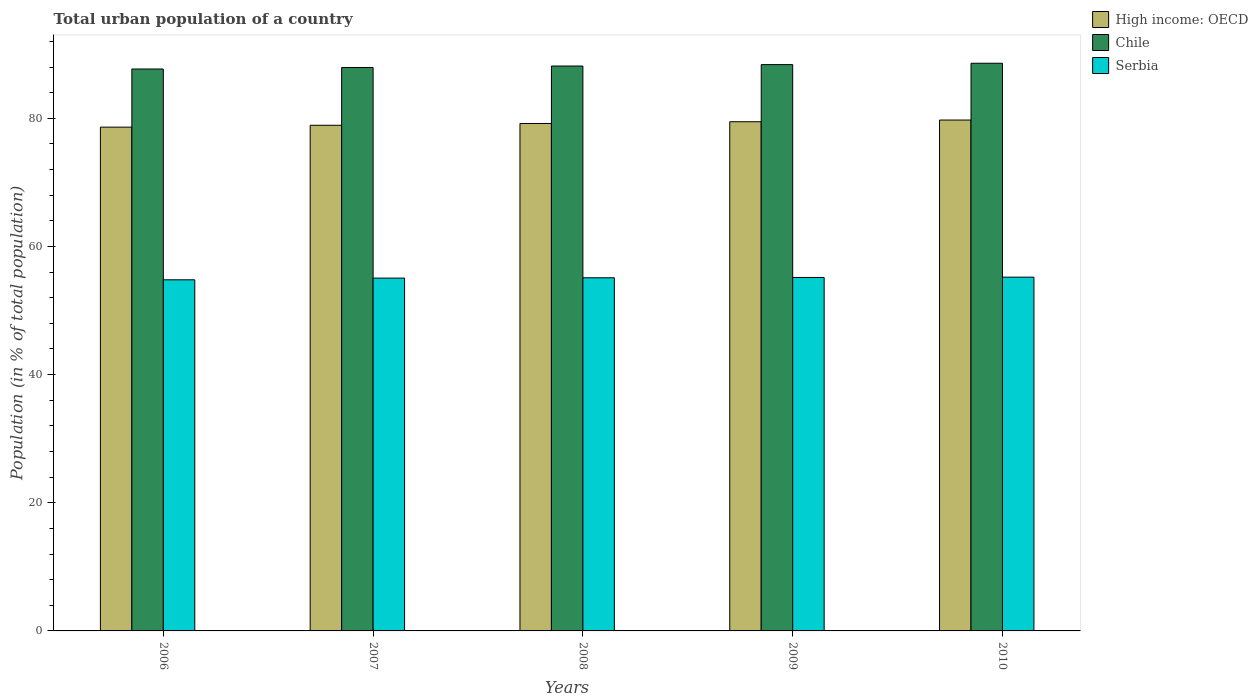Are the number of bars on each tick of the X-axis equal?
Your answer should be compact. Yes. How many bars are there on the 1st tick from the right?
Your answer should be very brief. 3. What is the label of the 5th group of bars from the left?
Your answer should be compact. 2010. In how many cases, is the number of bars for a given year not equal to the number of legend labels?
Keep it short and to the point. 0. What is the urban population in Chile in 2009?
Your answer should be very brief. 88.38. Across all years, what is the maximum urban population in Chile?
Provide a short and direct response. 88.59. Across all years, what is the minimum urban population in High income: OECD?
Offer a terse response. 78.62. In which year was the urban population in High income: OECD maximum?
Your answer should be compact. 2010. In which year was the urban population in Chile minimum?
Your answer should be compact. 2006. What is the total urban population in Chile in the graph?
Ensure brevity in your answer.  440.73. What is the difference between the urban population in High income: OECD in 2006 and that in 2009?
Keep it short and to the point. -0.84. What is the difference between the urban population in High income: OECD in 2008 and the urban population in Serbia in 2009?
Give a very brief answer. 24.03. What is the average urban population in Serbia per year?
Your answer should be very brief. 55.07. In the year 2006, what is the difference between the urban population in High income: OECD and urban population in Chile?
Provide a succinct answer. -9.07. What is the ratio of the urban population in Serbia in 2009 to that in 2010?
Your answer should be very brief. 1. Is the difference between the urban population in High income: OECD in 2007 and 2010 greater than the difference between the urban population in Chile in 2007 and 2010?
Give a very brief answer. No. What is the difference between the highest and the second highest urban population in High income: OECD?
Your response must be concise. 0.27. What is the difference between the highest and the lowest urban population in High income: OECD?
Your response must be concise. 1.11. Is the sum of the urban population in High income: OECD in 2008 and 2010 greater than the maximum urban population in Chile across all years?
Your response must be concise. Yes. What does the 3rd bar from the left in 2007 represents?
Your answer should be compact. Serbia. What does the 3rd bar from the right in 2008 represents?
Your response must be concise. High income: OECD. Is it the case that in every year, the sum of the urban population in Serbia and urban population in High income: OECD is greater than the urban population in Chile?
Ensure brevity in your answer.  Yes. How many bars are there?
Keep it short and to the point. 15. Are all the bars in the graph horizontal?
Your response must be concise. No. Are the values on the major ticks of Y-axis written in scientific E-notation?
Your response must be concise. No. How many legend labels are there?
Your answer should be very brief. 3. What is the title of the graph?
Your answer should be compact. Total urban population of a country. Does "Israel" appear as one of the legend labels in the graph?
Your answer should be compact. No. What is the label or title of the Y-axis?
Make the answer very short. Population (in % of total population). What is the Population (in % of total population) in High income: OECD in 2006?
Your answer should be very brief. 78.62. What is the Population (in % of total population) of Chile in 2006?
Provide a short and direct response. 87.69. What is the Population (in % of total population) of Serbia in 2006?
Provide a short and direct response. 54.79. What is the Population (in % of total population) of High income: OECD in 2007?
Provide a succinct answer. 78.91. What is the Population (in % of total population) in Chile in 2007?
Your answer should be compact. 87.93. What is the Population (in % of total population) in Serbia in 2007?
Provide a short and direct response. 55.06. What is the Population (in % of total population) of High income: OECD in 2008?
Offer a terse response. 79.19. What is the Population (in % of total population) of Chile in 2008?
Your answer should be compact. 88.16. What is the Population (in % of total population) of Serbia in 2008?
Provide a succinct answer. 55.11. What is the Population (in % of total population) of High income: OECD in 2009?
Ensure brevity in your answer.  79.46. What is the Population (in % of total population) in Chile in 2009?
Offer a terse response. 88.38. What is the Population (in % of total population) in Serbia in 2009?
Your answer should be compact. 55.16. What is the Population (in % of total population) in High income: OECD in 2010?
Your answer should be very brief. 79.72. What is the Population (in % of total population) in Chile in 2010?
Ensure brevity in your answer.  88.59. What is the Population (in % of total population) in Serbia in 2010?
Provide a short and direct response. 55.21. Across all years, what is the maximum Population (in % of total population) of High income: OECD?
Provide a succinct answer. 79.72. Across all years, what is the maximum Population (in % of total population) in Chile?
Your response must be concise. 88.59. Across all years, what is the maximum Population (in % of total population) in Serbia?
Provide a short and direct response. 55.21. Across all years, what is the minimum Population (in % of total population) in High income: OECD?
Provide a short and direct response. 78.62. Across all years, what is the minimum Population (in % of total population) of Chile?
Your answer should be compact. 87.69. Across all years, what is the minimum Population (in % of total population) in Serbia?
Your response must be concise. 54.79. What is the total Population (in % of total population) of High income: OECD in the graph?
Your answer should be compact. 395.9. What is the total Population (in % of total population) of Chile in the graph?
Your response must be concise. 440.73. What is the total Population (in % of total population) in Serbia in the graph?
Your answer should be very brief. 275.33. What is the difference between the Population (in % of total population) of High income: OECD in 2006 and that in 2007?
Provide a short and direct response. -0.29. What is the difference between the Population (in % of total population) of Chile in 2006 and that in 2007?
Your answer should be very brief. -0.24. What is the difference between the Population (in % of total population) in Serbia in 2006 and that in 2007?
Your response must be concise. -0.27. What is the difference between the Population (in % of total population) in High income: OECD in 2006 and that in 2008?
Provide a short and direct response. -0.57. What is the difference between the Population (in % of total population) in Chile in 2006 and that in 2008?
Offer a terse response. -0.47. What is the difference between the Population (in % of total population) of Serbia in 2006 and that in 2008?
Give a very brief answer. -0.32. What is the difference between the Population (in % of total population) of High income: OECD in 2006 and that in 2009?
Your response must be concise. -0.84. What is the difference between the Population (in % of total population) in Chile in 2006 and that in 2009?
Ensure brevity in your answer.  -0.69. What is the difference between the Population (in % of total population) of Serbia in 2006 and that in 2009?
Make the answer very short. -0.37. What is the difference between the Population (in % of total population) of High income: OECD in 2006 and that in 2010?
Your answer should be compact. -1.11. What is the difference between the Population (in % of total population) of Chile in 2006 and that in 2010?
Provide a succinct answer. -0.9. What is the difference between the Population (in % of total population) in Serbia in 2006 and that in 2010?
Your response must be concise. -0.41. What is the difference between the Population (in % of total population) of High income: OECD in 2007 and that in 2008?
Provide a short and direct response. -0.28. What is the difference between the Population (in % of total population) in Chile in 2007 and that in 2008?
Keep it short and to the point. -0.23. What is the difference between the Population (in % of total population) in Serbia in 2007 and that in 2008?
Keep it short and to the point. -0.05. What is the difference between the Population (in % of total population) of High income: OECD in 2007 and that in 2009?
Give a very brief answer. -0.55. What is the difference between the Population (in % of total population) in Chile in 2007 and that in 2009?
Provide a succinct answer. -0.45. What is the difference between the Population (in % of total population) of Serbia in 2007 and that in 2009?
Give a very brief answer. -0.1. What is the difference between the Population (in % of total population) in High income: OECD in 2007 and that in 2010?
Offer a terse response. -0.82. What is the difference between the Population (in % of total population) in Chile in 2007 and that in 2010?
Make the answer very short. -0.66. What is the difference between the Population (in % of total population) of Serbia in 2007 and that in 2010?
Your answer should be very brief. -0.15. What is the difference between the Population (in % of total population) of High income: OECD in 2008 and that in 2009?
Offer a very short reply. -0.27. What is the difference between the Population (in % of total population) in Chile in 2008 and that in 2009?
Your answer should be compact. -0.22. What is the difference between the Population (in % of total population) of Serbia in 2008 and that in 2009?
Provide a short and direct response. -0.05. What is the difference between the Population (in % of total population) of High income: OECD in 2008 and that in 2010?
Offer a terse response. -0.54. What is the difference between the Population (in % of total population) of Chile in 2008 and that in 2010?
Offer a terse response. -0.43. What is the difference between the Population (in % of total population) of Serbia in 2008 and that in 2010?
Your response must be concise. -0.1. What is the difference between the Population (in % of total population) in High income: OECD in 2009 and that in 2010?
Offer a terse response. -0.27. What is the difference between the Population (in % of total population) in Chile in 2009 and that in 2010?
Your response must be concise. -0.21. What is the difference between the Population (in % of total population) of Serbia in 2009 and that in 2010?
Provide a succinct answer. -0.05. What is the difference between the Population (in % of total population) in High income: OECD in 2006 and the Population (in % of total population) in Chile in 2007?
Your answer should be very brief. -9.31. What is the difference between the Population (in % of total population) in High income: OECD in 2006 and the Population (in % of total population) in Serbia in 2007?
Ensure brevity in your answer.  23.56. What is the difference between the Population (in % of total population) of Chile in 2006 and the Population (in % of total population) of Serbia in 2007?
Provide a succinct answer. 32.63. What is the difference between the Population (in % of total population) of High income: OECD in 2006 and the Population (in % of total population) of Chile in 2008?
Offer a very short reply. -9.54. What is the difference between the Population (in % of total population) in High income: OECD in 2006 and the Population (in % of total population) in Serbia in 2008?
Your answer should be very brief. 23.51. What is the difference between the Population (in % of total population) in Chile in 2006 and the Population (in % of total population) in Serbia in 2008?
Keep it short and to the point. 32.58. What is the difference between the Population (in % of total population) in High income: OECD in 2006 and the Population (in % of total population) in Chile in 2009?
Keep it short and to the point. -9.76. What is the difference between the Population (in % of total population) of High income: OECD in 2006 and the Population (in % of total population) of Serbia in 2009?
Your response must be concise. 23.46. What is the difference between the Population (in % of total population) of Chile in 2006 and the Population (in % of total population) of Serbia in 2009?
Offer a terse response. 32.53. What is the difference between the Population (in % of total population) of High income: OECD in 2006 and the Population (in % of total population) of Chile in 2010?
Your response must be concise. -9.97. What is the difference between the Population (in % of total population) of High income: OECD in 2006 and the Population (in % of total population) of Serbia in 2010?
Your answer should be compact. 23.41. What is the difference between the Population (in % of total population) of Chile in 2006 and the Population (in % of total population) of Serbia in 2010?
Keep it short and to the point. 32.48. What is the difference between the Population (in % of total population) in High income: OECD in 2007 and the Population (in % of total population) in Chile in 2008?
Your answer should be compact. -9.25. What is the difference between the Population (in % of total population) in High income: OECD in 2007 and the Population (in % of total population) in Serbia in 2008?
Make the answer very short. 23.8. What is the difference between the Population (in % of total population) in Chile in 2007 and the Population (in % of total population) in Serbia in 2008?
Provide a short and direct response. 32.82. What is the difference between the Population (in % of total population) of High income: OECD in 2007 and the Population (in % of total population) of Chile in 2009?
Ensure brevity in your answer.  -9.47. What is the difference between the Population (in % of total population) in High income: OECD in 2007 and the Population (in % of total population) in Serbia in 2009?
Provide a short and direct response. 23.75. What is the difference between the Population (in % of total population) in Chile in 2007 and the Population (in % of total population) in Serbia in 2009?
Make the answer very short. 32.77. What is the difference between the Population (in % of total population) of High income: OECD in 2007 and the Population (in % of total population) of Chile in 2010?
Your response must be concise. -9.68. What is the difference between the Population (in % of total population) of High income: OECD in 2007 and the Population (in % of total population) of Serbia in 2010?
Your answer should be compact. 23.7. What is the difference between the Population (in % of total population) of Chile in 2007 and the Population (in % of total population) of Serbia in 2010?
Offer a very short reply. 32.72. What is the difference between the Population (in % of total population) in High income: OECD in 2008 and the Population (in % of total population) in Chile in 2009?
Make the answer very short. -9.19. What is the difference between the Population (in % of total population) of High income: OECD in 2008 and the Population (in % of total population) of Serbia in 2009?
Give a very brief answer. 24.03. What is the difference between the Population (in % of total population) of Chile in 2008 and the Population (in % of total population) of Serbia in 2009?
Offer a very short reply. 33. What is the difference between the Population (in % of total population) of High income: OECD in 2008 and the Population (in % of total population) of Chile in 2010?
Provide a short and direct response. -9.4. What is the difference between the Population (in % of total population) in High income: OECD in 2008 and the Population (in % of total population) in Serbia in 2010?
Provide a succinct answer. 23.98. What is the difference between the Population (in % of total population) in Chile in 2008 and the Population (in % of total population) in Serbia in 2010?
Ensure brevity in your answer.  32.95. What is the difference between the Population (in % of total population) of High income: OECD in 2009 and the Population (in % of total population) of Chile in 2010?
Make the answer very short. -9.13. What is the difference between the Population (in % of total population) of High income: OECD in 2009 and the Population (in % of total population) of Serbia in 2010?
Your answer should be very brief. 24.25. What is the difference between the Population (in % of total population) of Chile in 2009 and the Population (in % of total population) of Serbia in 2010?
Your answer should be very brief. 33.17. What is the average Population (in % of total population) of High income: OECD per year?
Ensure brevity in your answer.  79.18. What is the average Population (in % of total population) of Chile per year?
Make the answer very short. 88.15. What is the average Population (in % of total population) of Serbia per year?
Make the answer very short. 55.07. In the year 2006, what is the difference between the Population (in % of total population) of High income: OECD and Population (in % of total population) of Chile?
Keep it short and to the point. -9.07. In the year 2006, what is the difference between the Population (in % of total population) of High income: OECD and Population (in % of total population) of Serbia?
Your response must be concise. 23.83. In the year 2006, what is the difference between the Population (in % of total population) in Chile and Population (in % of total population) in Serbia?
Your response must be concise. 32.9. In the year 2007, what is the difference between the Population (in % of total population) of High income: OECD and Population (in % of total population) of Chile?
Your answer should be compact. -9.02. In the year 2007, what is the difference between the Population (in % of total population) of High income: OECD and Population (in % of total population) of Serbia?
Your answer should be compact. 23.85. In the year 2007, what is the difference between the Population (in % of total population) in Chile and Population (in % of total population) in Serbia?
Offer a terse response. 32.87. In the year 2008, what is the difference between the Population (in % of total population) in High income: OECD and Population (in % of total population) in Chile?
Ensure brevity in your answer.  -8.97. In the year 2008, what is the difference between the Population (in % of total population) in High income: OECD and Population (in % of total population) in Serbia?
Give a very brief answer. 24.08. In the year 2008, what is the difference between the Population (in % of total population) in Chile and Population (in % of total population) in Serbia?
Offer a very short reply. 33.05. In the year 2009, what is the difference between the Population (in % of total population) in High income: OECD and Population (in % of total population) in Chile?
Your response must be concise. -8.92. In the year 2009, what is the difference between the Population (in % of total population) of High income: OECD and Population (in % of total population) of Serbia?
Give a very brief answer. 24.3. In the year 2009, what is the difference between the Population (in % of total population) in Chile and Population (in % of total population) in Serbia?
Give a very brief answer. 33.22. In the year 2010, what is the difference between the Population (in % of total population) of High income: OECD and Population (in % of total population) of Chile?
Your answer should be very brief. -8.86. In the year 2010, what is the difference between the Population (in % of total population) in High income: OECD and Population (in % of total population) in Serbia?
Offer a terse response. 24.52. In the year 2010, what is the difference between the Population (in % of total population) of Chile and Population (in % of total population) of Serbia?
Provide a short and direct response. 33.38. What is the ratio of the Population (in % of total population) of High income: OECD in 2006 to that in 2007?
Your response must be concise. 1. What is the ratio of the Population (in % of total population) in Serbia in 2006 to that in 2007?
Make the answer very short. 1. What is the ratio of the Population (in % of total population) of High income: OECD in 2006 to that in 2008?
Keep it short and to the point. 0.99. What is the ratio of the Population (in % of total population) in High income: OECD in 2006 to that in 2010?
Give a very brief answer. 0.99. What is the ratio of the Population (in % of total population) in High income: OECD in 2007 to that in 2008?
Provide a succinct answer. 1. What is the ratio of the Population (in % of total population) of Chile in 2007 to that in 2008?
Your answer should be compact. 1. What is the ratio of the Population (in % of total population) in Chile in 2007 to that in 2009?
Give a very brief answer. 0.99. What is the ratio of the Population (in % of total population) in High income: OECD in 2007 to that in 2010?
Provide a short and direct response. 0.99. What is the ratio of the Population (in % of total population) in Chile in 2007 to that in 2010?
Offer a very short reply. 0.99. What is the ratio of the Population (in % of total population) of High income: OECD in 2008 to that in 2009?
Offer a terse response. 1. What is the ratio of the Population (in % of total population) in Chile in 2008 to that in 2009?
Your answer should be compact. 1. What is the ratio of the Population (in % of total population) of Chile in 2008 to that in 2010?
Your answer should be very brief. 1. What is the ratio of the Population (in % of total population) in Serbia in 2008 to that in 2010?
Keep it short and to the point. 1. What is the ratio of the Population (in % of total population) in Chile in 2009 to that in 2010?
Make the answer very short. 1. What is the ratio of the Population (in % of total population) in Serbia in 2009 to that in 2010?
Your response must be concise. 1. What is the difference between the highest and the second highest Population (in % of total population) in High income: OECD?
Your answer should be very brief. 0.27. What is the difference between the highest and the second highest Population (in % of total population) of Chile?
Your answer should be compact. 0.21. What is the difference between the highest and the second highest Population (in % of total population) of Serbia?
Offer a terse response. 0.05. What is the difference between the highest and the lowest Population (in % of total population) in High income: OECD?
Your answer should be compact. 1.11. What is the difference between the highest and the lowest Population (in % of total population) of Chile?
Your answer should be compact. 0.9. What is the difference between the highest and the lowest Population (in % of total population) in Serbia?
Your response must be concise. 0.41. 